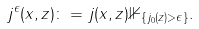Convert formula to latex. <formula><loc_0><loc_0><loc_500><loc_500>j ^ { \epsilon } ( x , z ) \colon = j ( x , z ) \mathbb { 1 } _ { \{ j _ { 0 } ( z ) > \epsilon \} } .</formula> 